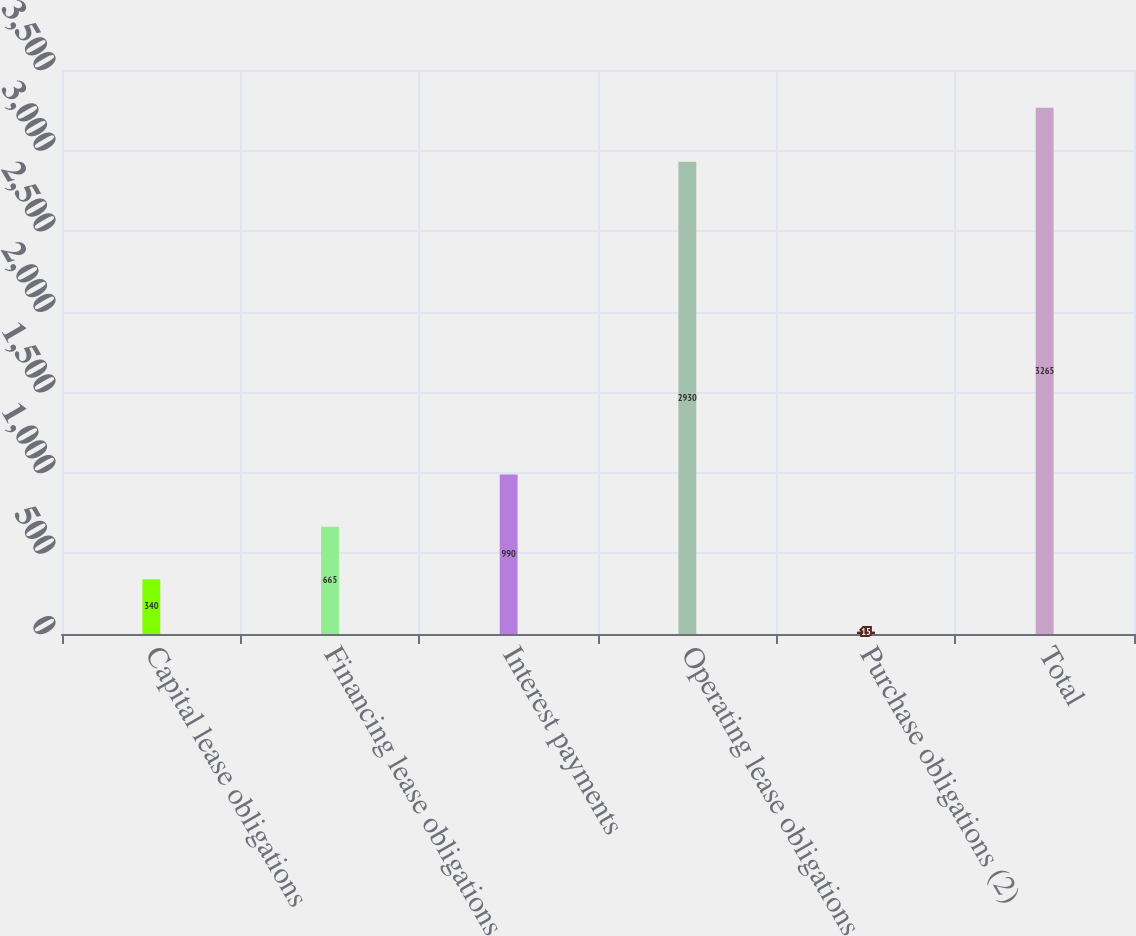<chart> <loc_0><loc_0><loc_500><loc_500><bar_chart><fcel>Capital lease obligations<fcel>Financing lease obligations<fcel>Interest payments<fcel>Operating lease obligations<fcel>Purchase obligations (2)<fcel>Total<nl><fcel>340<fcel>665<fcel>990<fcel>2930<fcel>15<fcel>3265<nl></chart> 